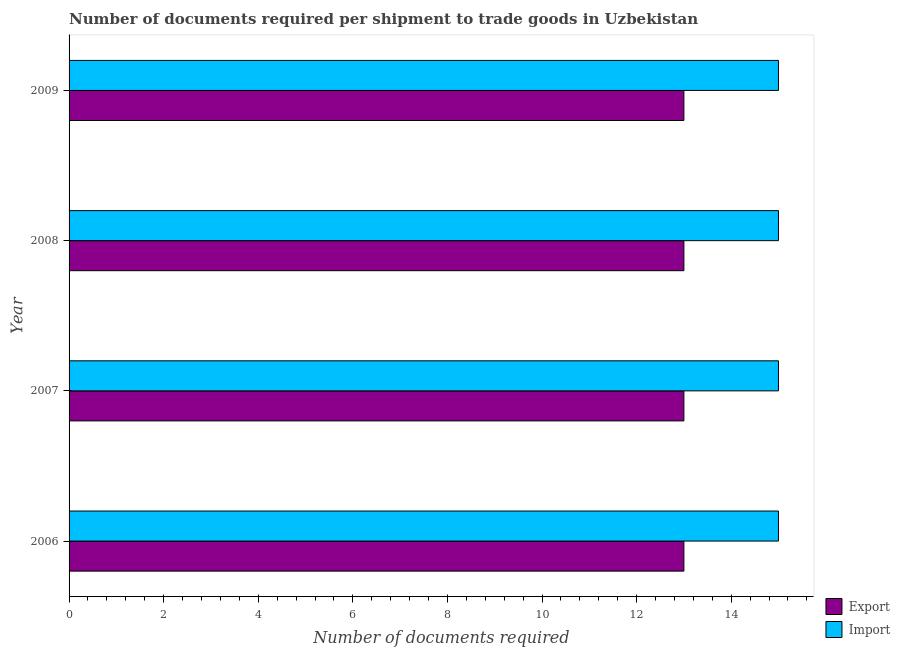Are the number of bars on each tick of the Y-axis equal?
Your answer should be compact. Yes. How many bars are there on the 2nd tick from the bottom?
Ensure brevity in your answer.  2. What is the number of documents required to import goods in 2009?
Provide a succinct answer. 15. Across all years, what is the maximum number of documents required to import goods?
Your answer should be compact. 15. Across all years, what is the minimum number of documents required to export goods?
Keep it short and to the point. 13. In which year was the number of documents required to export goods minimum?
Your answer should be very brief. 2006. What is the total number of documents required to export goods in the graph?
Your answer should be very brief. 52. What is the difference between the number of documents required to import goods in 2006 and that in 2009?
Offer a very short reply. 0. What is the difference between the number of documents required to import goods in 2008 and the number of documents required to export goods in 2009?
Make the answer very short. 2. What is the average number of documents required to export goods per year?
Your answer should be compact. 13. In the year 2006, what is the difference between the number of documents required to import goods and number of documents required to export goods?
Your response must be concise. 2. In how many years, is the number of documents required to import goods greater than 13.6 ?
Give a very brief answer. 4. Is the number of documents required to import goods in 2007 less than that in 2009?
Ensure brevity in your answer.  No. Is the difference between the number of documents required to export goods in 2006 and 2009 greater than the difference between the number of documents required to import goods in 2006 and 2009?
Your answer should be very brief. No. What is the difference between the highest and the second highest number of documents required to import goods?
Give a very brief answer. 0. What is the difference between the highest and the lowest number of documents required to export goods?
Your answer should be very brief. 0. Is the sum of the number of documents required to export goods in 2006 and 2008 greater than the maximum number of documents required to import goods across all years?
Give a very brief answer. Yes. What does the 1st bar from the top in 2009 represents?
Give a very brief answer. Import. What does the 2nd bar from the bottom in 2007 represents?
Offer a terse response. Import. How many bars are there?
Make the answer very short. 8. Are all the bars in the graph horizontal?
Provide a succinct answer. Yes. Are the values on the major ticks of X-axis written in scientific E-notation?
Give a very brief answer. No. Does the graph contain grids?
Give a very brief answer. No. How are the legend labels stacked?
Your answer should be very brief. Vertical. What is the title of the graph?
Your answer should be very brief. Number of documents required per shipment to trade goods in Uzbekistan. What is the label or title of the X-axis?
Your answer should be very brief. Number of documents required. What is the Number of documents required in Export in 2006?
Your answer should be compact. 13. What is the Number of documents required of Import in 2006?
Offer a terse response. 15. What is the Number of documents required in Export in 2008?
Keep it short and to the point. 13. What is the Number of documents required in Export in 2009?
Your answer should be compact. 13. What is the Number of documents required of Import in 2009?
Keep it short and to the point. 15. Across all years, what is the maximum Number of documents required in Import?
Provide a short and direct response. 15. Across all years, what is the minimum Number of documents required of Export?
Make the answer very short. 13. What is the total Number of documents required in Export in the graph?
Keep it short and to the point. 52. What is the difference between the Number of documents required in Export in 2006 and that in 2008?
Provide a short and direct response. 0. What is the difference between the Number of documents required in Export in 2006 and that in 2009?
Keep it short and to the point. 0. What is the difference between the Number of documents required in Export in 2007 and that in 2009?
Offer a terse response. 0. What is the difference between the Number of documents required of Import in 2007 and that in 2009?
Your answer should be very brief. 0. What is the difference between the Number of documents required in Export in 2008 and that in 2009?
Keep it short and to the point. 0. What is the difference between the Number of documents required of Import in 2008 and that in 2009?
Your answer should be compact. 0. What is the difference between the Number of documents required of Export in 2006 and the Number of documents required of Import in 2007?
Ensure brevity in your answer.  -2. What is the difference between the Number of documents required in Export in 2006 and the Number of documents required in Import in 2009?
Make the answer very short. -2. What is the difference between the Number of documents required of Export in 2008 and the Number of documents required of Import in 2009?
Your answer should be very brief. -2. What is the average Number of documents required of Export per year?
Keep it short and to the point. 13. In the year 2008, what is the difference between the Number of documents required in Export and Number of documents required in Import?
Make the answer very short. -2. What is the ratio of the Number of documents required of Import in 2006 to that in 2007?
Give a very brief answer. 1. What is the ratio of the Number of documents required in Import in 2006 to that in 2008?
Your answer should be very brief. 1. What is the ratio of the Number of documents required in Export in 2006 to that in 2009?
Ensure brevity in your answer.  1. What is the ratio of the Number of documents required of Import in 2007 to that in 2008?
Your answer should be compact. 1. What is the ratio of the Number of documents required in Export in 2007 to that in 2009?
Offer a terse response. 1. What is the difference between the highest and the second highest Number of documents required in Export?
Keep it short and to the point. 0. What is the difference between the highest and the lowest Number of documents required of Export?
Provide a short and direct response. 0. What is the difference between the highest and the lowest Number of documents required of Import?
Give a very brief answer. 0. 